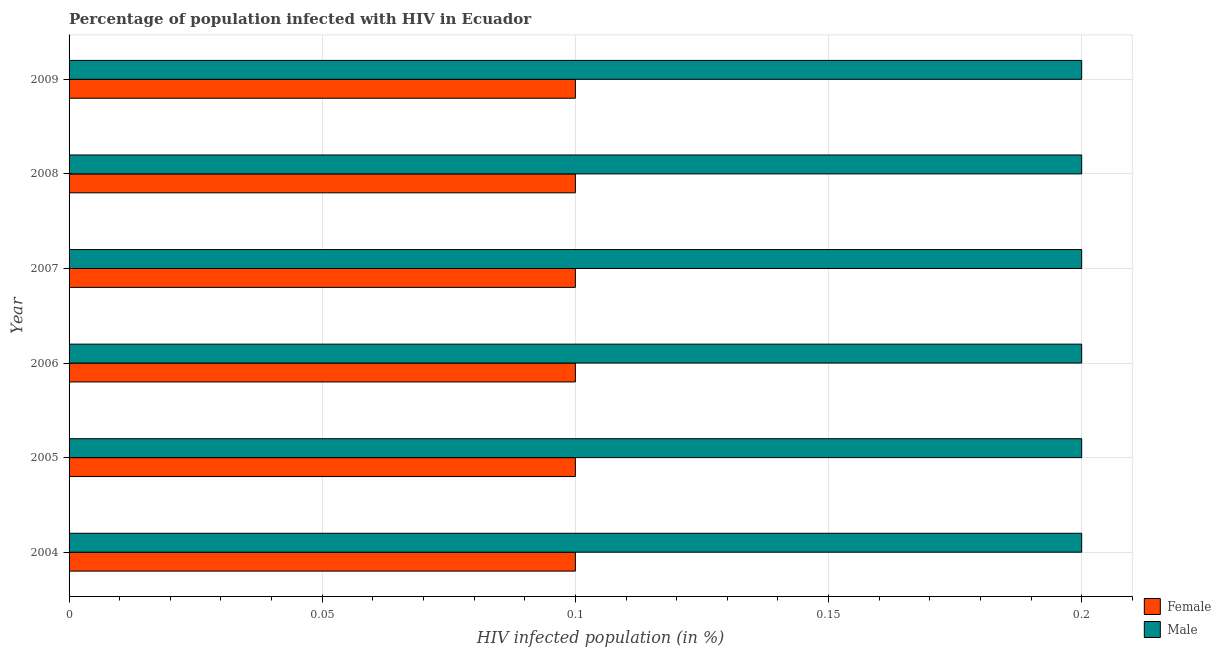How many different coloured bars are there?
Keep it short and to the point. 2. Are the number of bars per tick equal to the number of legend labels?
Your response must be concise. Yes. How many bars are there on the 6th tick from the top?
Keep it short and to the point. 2. What is the label of the 4th group of bars from the top?
Ensure brevity in your answer.  2006. What is the percentage of females who are infected with hiv in 2007?
Provide a short and direct response. 0.1. Across all years, what is the maximum percentage of females who are infected with hiv?
Your answer should be compact. 0.1. Across all years, what is the minimum percentage of males who are infected with hiv?
Your response must be concise. 0.2. In which year was the percentage of males who are infected with hiv maximum?
Keep it short and to the point. 2004. In which year was the percentage of males who are infected with hiv minimum?
Your answer should be compact. 2004. What is the total percentage of males who are infected with hiv in the graph?
Keep it short and to the point. 1.2. What is the difference between the percentage of females who are infected with hiv in 2008 and that in 2009?
Ensure brevity in your answer.  0. What is the difference between the percentage of males who are infected with hiv in 2004 and the percentage of females who are infected with hiv in 2009?
Offer a terse response. 0.1. What is the average percentage of males who are infected with hiv per year?
Offer a terse response. 0.2. In how many years, is the percentage of females who are infected with hiv greater than 0.07 %?
Make the answer very short. 6. What is the ratio of the percentage of males who are infected with hiv in 2006 to that in 2007?
Provide a succinct answer. 1. Is the difference between the percentage of females who are infected with hiv in 2004 and 2007 greater than the difference between the percentage of males who are infected with hiv in 2004 and 2007?
Your answer should be very brief. No. In how many years, is the percentage of males who are infected with hiv greater than the average percentage of males who are infected with hiv taken over all years?
Make the answer very short. 6. Is the sum of the percentage of males who are infected with hiv in 2005 and 2007 greater than the maximum percentage of females who are infected with hiv across all years?
Offer a terse response. Yes. How many bars are there?
Make the answer very short. 12. How many years are there in the graph?
Your response must be concise. 6. What is the difference between two consecutive major ticks on the X-axis?
Give a very brief answer. 0.05. Does the graph contain any zero values?
Offer a terse response. No. What is the title of the graph?
Provide a succinct answer. Percentage of population infected with HIV in Ecuador. What is the label or title of the X-axis?
Provide a short and direct response. HIV infected population (in %). What is the label or title of the Y-axis?
Keep it short and to the point. Year. What is the HIV infected population (in %) in Female in 2005?
Your answer should be very brief. 0.1. What is the HIV infected population (in %) in Male in 2005?
Keep it short and to the point. 0.2. What is the HIV infected population (in %) of Female in 2006?
Your answer should be compact. 0.1. What is the HIV infected population (in %) in Female in 2007?
Offer a very short reply. 0.1. What is the HIV infected population (in %) of Female in 2008?
Make the answer very short. 0.1. Across all years, what is the minimum HIV infected population (in %) of Female?
Ensure brevity in your answer.  0.1. Across all years, what is the minimum HIV infected population (in %) in Male?
Provide a succinct answer. 0.2. What is the total HIV infected population (in %) in Female in the graph?
Keep it short and to the point. 0.6. What is the total HIV infected population (in %) of Male in the graph?
Keep it short and to the point. 1.2. What is the difference between the HIV infected population (in %) of Female in 2004 and that in 2005?
Keep it short and to the point. 0. What is the difference between the HIV infected population (in %) of Male in 2004 and that in 2005?
Your answer should be very brief. 0. What is the difference between the HIV infected population (in %) of Female in 2004 and that in 2009?
Provide a short and direct response. 0. What is the difference between the HIV infected population (in %) in Female in 2005 and that in 2006?
Your answer should be very brief. 0. What is the difference between the HIV infected population (in %) in Female in 2005 and that in 2008?
Your answer should be very brief. 0. What is the difference between the HIV infected population (in %) in Female in 2005 and that in 2009?
Keep it short and to the point. 0. What is the difference between the HIV infected population (in %) in Male in 2005 and that in 2009?
Offer a terse response. 0. What is the difference between the HIV infected population (in %) in Female in 2006 and that in 2007?
Make the answer very short. 0. What is the difference between the HIV infected population (in %) in Male in 2006 and that in 2007?
Your response must be concise. 0. What is the difference between the HIV infected population (in %) in Female in 2006 and that in 2008?
Offer a very short reply. 0. What is the difference between the HIV infected population (in %) in Male in 2007 and that in 2008?
Provide a succinct answer. 0. What is the difference between the HIV infected population (in %) in Female in 2007 and that in 2009?
Give a very brief answer. 0. What is the difference between the HIV infected population (in %) of Male in 2008 and that in 2009?
Offer a very short reply. 0. What is the difference between the HIV infected population (in %) in Female in 2004 and the HIV infected population (in %) in Male in 2005?
Offer a very short reply. -0.1. What is the difference between the HIV infected population (in %) in Female in 2004 and the HIV infected population (in %) in Male in 2007?
Offer a terse response. -0.1. What is the difference between the HIV infected population (in %) in Female in 2005 and the HIV infected population (in %) in Male in 2006?
Offer a very short reply. -0.1. What is the difference between the HIV infected population (in %) in Female in 2005 and the HIV infected population (in %) in Male in 2007?
Keep it short and to the point. -0.1. What is the difference between the HIV infected population (in %) of Female in 2007 and the HIV infected population (in %) of Male in 2008?
Your answer should be compact. -0.1. What is the average HIV infected population (in %) of Female per year?
Give a very brief answer. 0.1. In the year 2006, what is the difference between the HIV infected population (in %) in Female and HIV infected population (in %) in Male?
Your response must be concise. -0.1. In the year 2008, what is the difference between the HIV infected population (in %) in Female and HIV infected population (in %) in Male?
Your answer should be very brief. -0.1. In the year 2009, what is the difference between the HIV infected population (in %) in Female and HIV infected population (in %) in Male?
Your response must be concise. -0.1. What is the ratio of the HIV infected population (in %) in Female in 2004 to that in 2005?
Your answer should be compact. 1. What is the ratio of the HIV infected population (in %) in Female in 2004 to that in 2006?
Keep it short and to the point. 1. What is the ratio of the HIV infected population (in %) in Female in 2004 to that in 2007?
Make the answer very short. 1. What is the ratio of the HIV infected population (in %) of Male in 2004 to that in 2007?
Provide a succinct answer. 1. What is the ratio of the HIV infected population (in %) of Female in 2004 to that in 2008?
Provide a short and direct response. 1. What is the ratio of the HIV infected population (in %) in Female in 2004 to that in 2009?
Your answer should be compact. 1. What is the ratio of the HIV infected population (in %) in Female in 2005 to that in 2007?
Ensure brevity in your answer.  1. What is the ratio of the HIV infected population (in %) in Female in 2005 to that in 2008?
Offer a very short reply. 1. What is the ratio of the HIV infected population (in %) in Male in 2005 to that in 2008?
Provide a short and direct response. 1. What is the ratio of the HIV infected population (in %) of Female in 2005 to that in 2009?
Your answer should be compact. 1. What is the ratio of the HIV infected population (in %) in Female in 2006 to that in 2007?
Your answer should be compact. 1. What is the ratio of the HIV infected population (in %) in Male in 2006 to that in 2007?
Ensure brevity in your answer.  1. What is the ratio of the HIV infected population (in %) of Female in 2007 to that in 2008?
Give a very brief answer. 1. What is the ratio of the HIV infected population (in %) in Male in 2007 to that in 2008?
Ensure brevity in your answer.  1. What is the ratio of the HIV infected population (in %) of Female in 2008 to that in 2009?
Your response must be concise. 1. What is the ratio of the HIV infected population (in %) in Male in 2008 to that in 2009?
Your answer should be very brief. 1. What is the difference between the highest and the lowest HIV infected population (in %) of Female?
Give a very brief answer. 0. What is the difference between the highest and the lowest HIV infected population (in %) in Male?
Your answer should be compact. 0. 